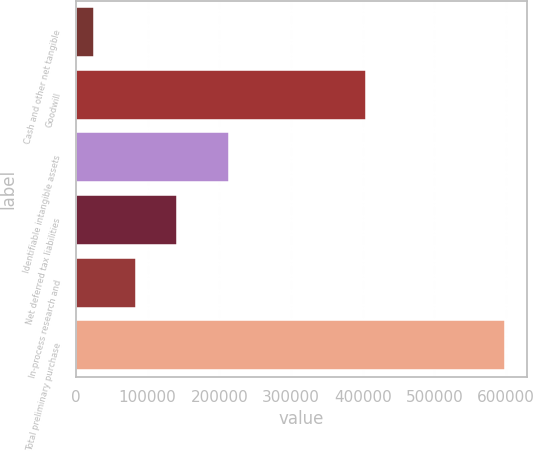<chart> <loc_0><loc_0><loc_500><loc_500><bar_chart><fcel>Cash and other net tangible<fcel>Goodwill<fcel>Identifiable intangible assets<fcel>Net deferred tax liabilities<fcel>In-process research and<fcel>Total preliminary purchase<nl><fcel>25856<fcel>404280<fcel>213900<fcel>140369<fcel>83112.5<fcel>598421<nl></chart> 